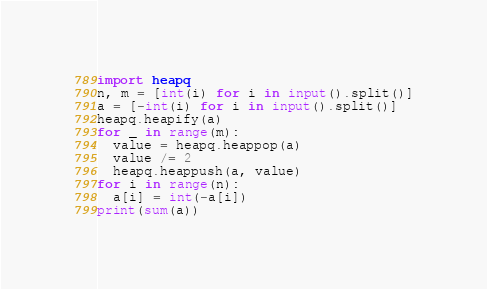<code> <loc_0><loc_0><loc_500><loc_500><_Python_>import heapq
n, m = [int(i) for i in input().split()]
a = [-int(i) for i in input().split()]
heapq.heapify(a)
for _ in range(m):
  value = heapq.heappop(a)
  value /= 2
  heapq.heappush(a, value)
for i in range(n):
  a[i] = int(-a[i])
print(sum(a))</code> 